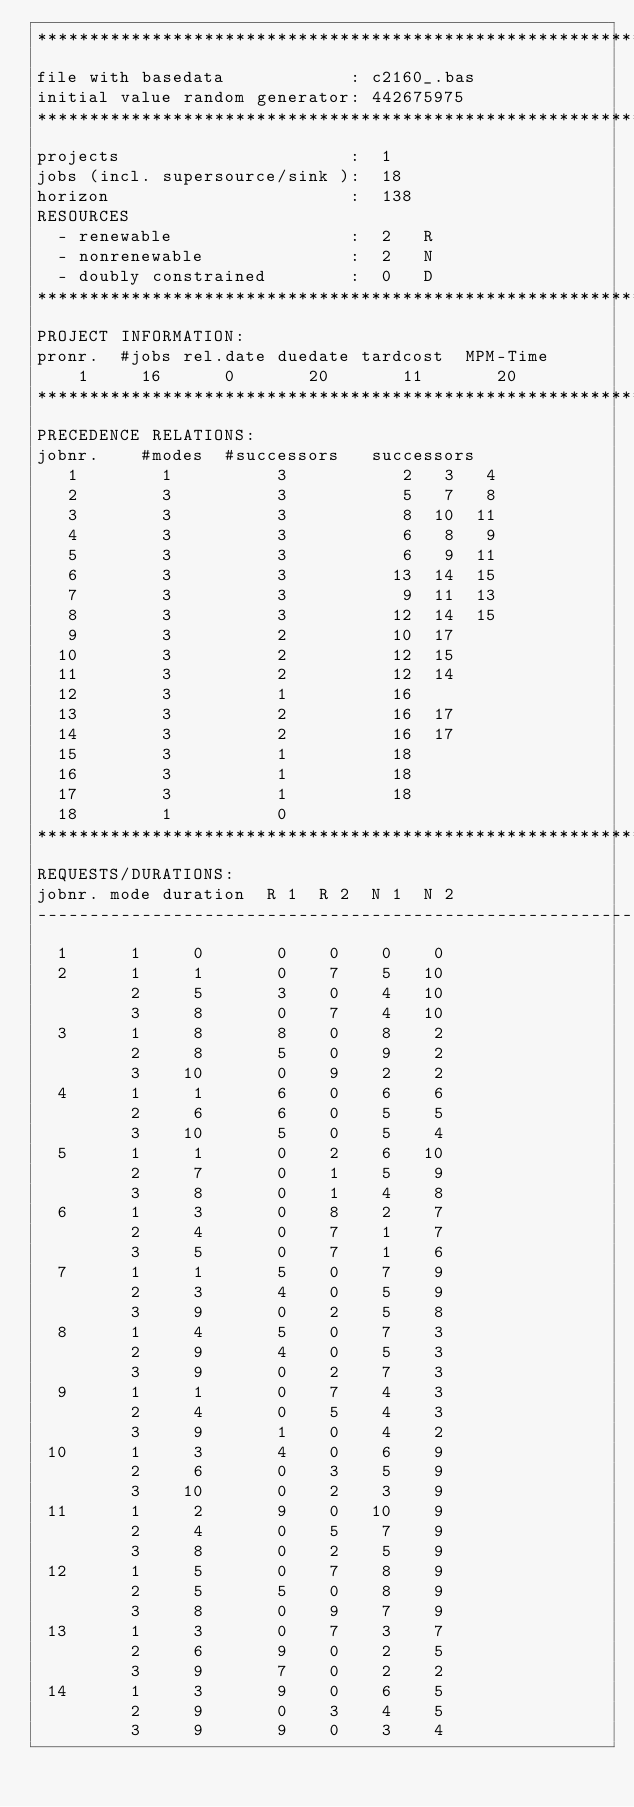Convert code to text. <code><loc_0><loc_0><loc_500><loc_500><_ObjectiveC_>************************************************************************
file with basedata            : c2160_.bas
initial value random generator: 442675975
************************************************************************
projects                      :  1
jobs (incl. supersource/sink ):  18
horizon                       :  138
RESOURCES
  - renewable                 :  2   R
  - nonrenewable              :  2   N
  - doubly constrained        :  0   D
************************************************************************
PROJECT INFORMATION:
pronr.  #jobs rel.date duedate tardcost  MPM-Time
    1     16      0       20       11       20
************************************************************************
PRECEDENCE RELATIONS:
jobnr.    #modes  #successors   successors
   1        1          3           2   3   4
   2        3          3           5   7   8
   3        3          3           8  10  11
   4        3          3           6   8   9
   5        3          3           6   9  11
   6        3          3          13  14  15
   7        3          3           9  11  13
   8        3          3          12  14  15
   9        3          2          10  17
  10        3          2          12  15
  11        3          2          12  14
  12        3          1          16
  13        3          2          16  17
  14        3          2          16  17
  15        3          1          18
  16        3          1          18
  17        3          1          18
  18        1          0        
************************************************************************
REQUESTS/DURATIONS:
jobnr. mode duration  R 1  R 2  N 1  N 2
------------------------------------------------------------------------
  1      1     0       0    0    0    0
  2      1     1       0    7    5   10
         2     5       3    0    4   10
         3     8       0    7    4   10
  3      1     8       8    0    8    2
         2     8       5    0    9    2
         3    10       0    9    2    2
  4      1     1       6    0    6    6
         2     6       6    0    5    5
         3    10       5    0    5    4
  5      1     1       0    2    6   10
         2     7       0    1    5    9
         3     8       0    1    4    8
  6      1     3       0    8    2    7
         2     4       0    7    1    7
         3     5       0    7    1    6
  7      1     1       5    0    7    9
         2     3       4    0    5    9
         3     9       0    2    5    8
  8      1     4       5    0    7    3
         2     9       4    0    5    3
         3     9       0    2    7    3
  9      1     1       0    7    4    3
         2     4       0    5    4    3
         3     9       1    0    4    2
 10      1     3       4    0    6    9
         2     6       0    3    5    9
         3    10       0    2    3    9
 11      1     2       9    0   10    9
         2     4       0    5    7    9
         3     8       0    2    5    9
 12      1     5       0    7    8    9
         2     5       5    0    8    9
         3     8       0    9    7    9
 13      1     3       0    7    3    7
         2     6       9    0    2    5
         3     9       7    0    2    2
 14      1     3       9    0    6    5
         2     9       0    3    4    5
         3     9       9    0    3    4</code> 